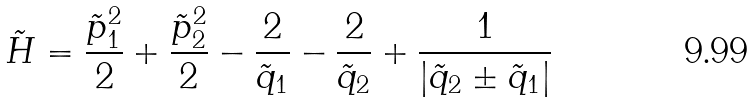<formula> <loc_0><loc_0><loc_500><loc_500>\tilde { H } = \frac { \tilde { p } _ { 1 } ^ { 2 } } { 2 } + \frac { \tilde { p } _ { 2 } ^ { 2 } } { 2 } - \frac { 2 } { \tilde { q } _ { 1 } } - \frac { 2 } { \tilde { q } _ { 2 } } + \frac { 1 } { | \tilde { q } _ { 2 } \pm \tilde { q } _ { 1 } | }</formula> 